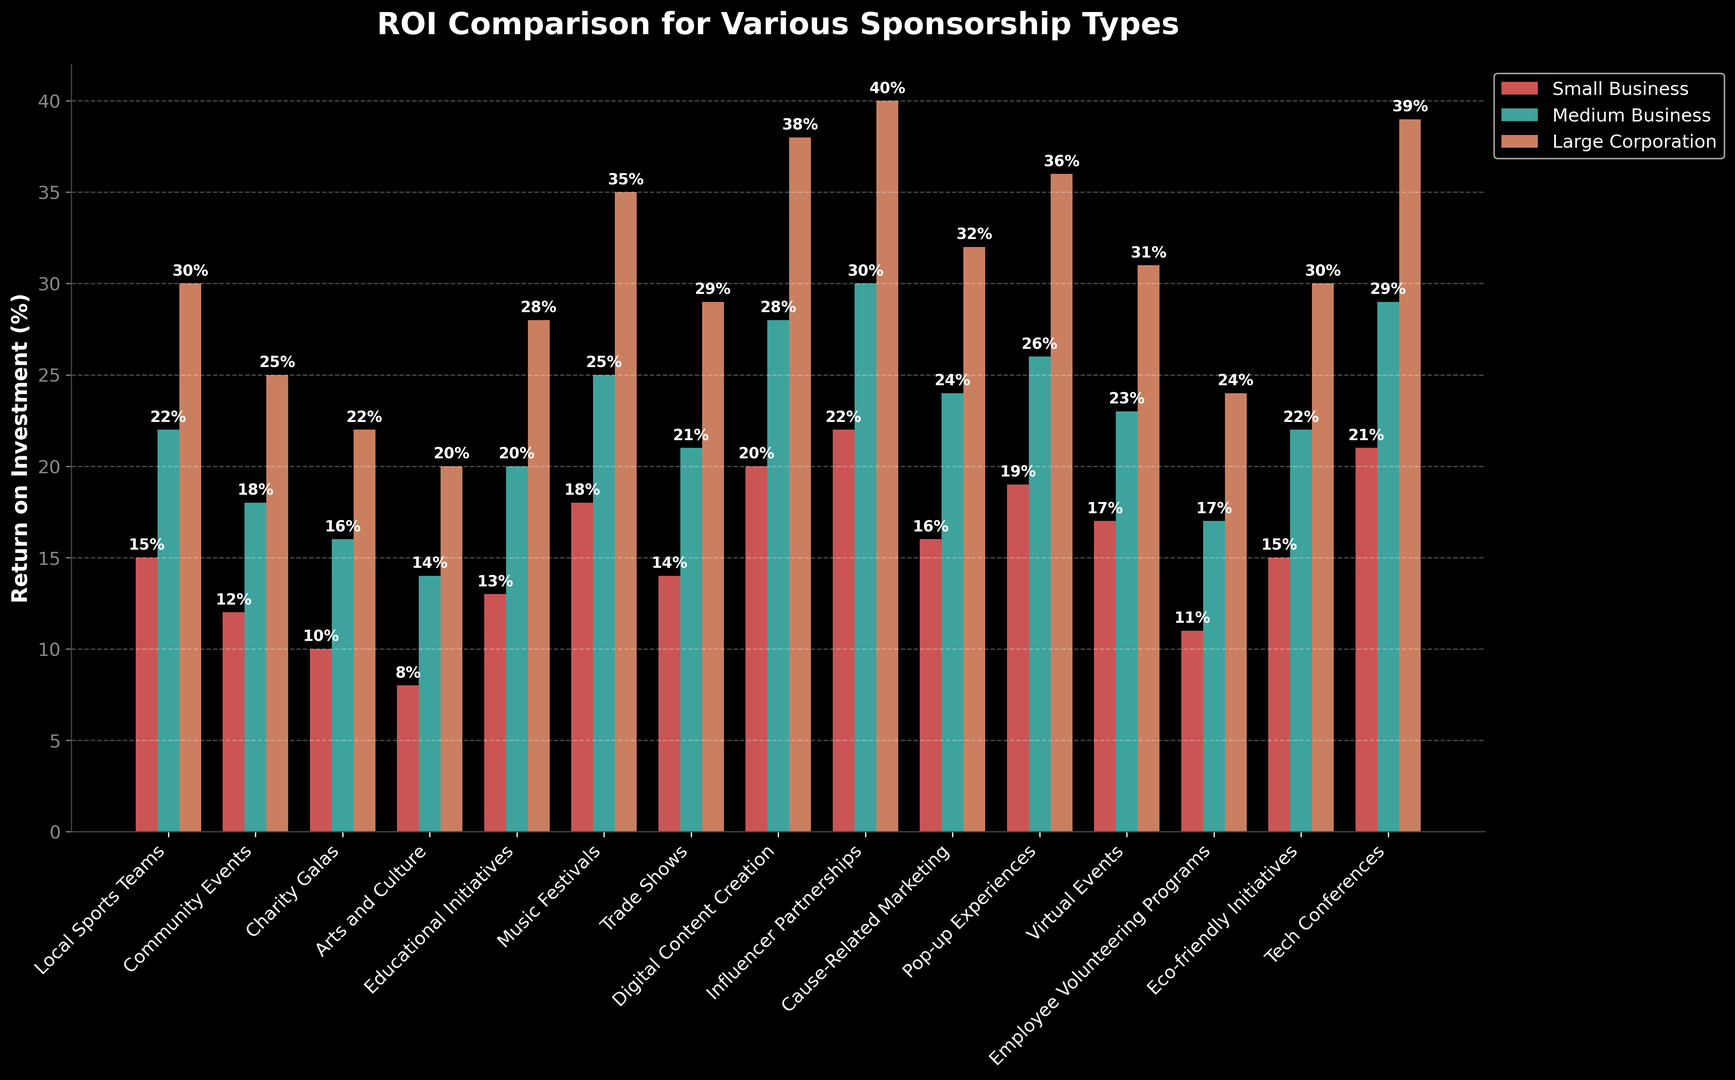What's the highest ROI percentage for small businesses? To find the highest ROI percentage for small businesses, look at the heights of the red bars for different sponsorship types. The highest bar represents the "Influencer Partnerships" with an ROI of 22%.
Answer: 22% Which sponsorship type has the lowest ROI for medium businesses? To determine the lowest ROI for medium businesses, compare the heights of all the green bars. The shortest green bar is for "Arts and Culture" with an ROI of 14%.
Answer: Arts and Culture For large corporations, which two sponsorship types have the same ROI? Observe the heights of the orange bars and find any two bars that are of equal height. Both "Local Sports Teams" and "Eco-friendly Initiatives" have an ROI of 30%.
Answer: Local Sports Teams and Eco-friendly Initiatives How much higher is the ROI for digital content creation compared to trade shows for small businesses? Look at the red bars for both "Digital Content Creation" and "Trade Shows." "Digital Content Creation" has an ROI of 20%, and "Trade Shows" has an ROI of 14%. Calculate the difference: 20% - 14% = 6%.
Answer: 6% Which sponsorship type shows the highest average ROI across all business types? Calculate the average ROI for each sponsorship type by adding the ROI percentages for small, medium, and large businesses and dividing by 3. The "Influencer Partnerships" have averages of (22% + 30% + 40%)/3 = 30%, the highest among all.
Answer: Influencer Partnerships Compare the ROI for educational initiatives between small and medium businesses. Which one is higher? Compare the heights of the red bar (small business) and the green bar (medium business) for "Educational Initiatives". The red bar is 13%, and the green bar is 20%. The medium business has a higher ROI.
Answer: Medium Business What is the combined ROI for large corporations in both music festivals and tech conferences? Sum the ROI percentages for large corporations in "Music Festivals" (35%) and "Tech Conferences" (39%): 35% + 39% = 74%.
Answer: 74% How does the ROI for cause-related marketing compare to virtual events for medium businesses? Compare the heights of the green bars for "Cause-Related Marketing" (24%) and "Virtual Events" (23%). The ROI for "Cause-Related Marketing" is slightly higher.
Answer: Cause-Related Marketing Which sponsorship type has the closest ROI values across all business types? Look for sponsorship types where the red, green, and orange bars are nearly the same height. "Community Events" have ROI of 12% (small), 18% (medium), and 25% (large), which are relatively close compared to the other categories.
Answer: Community Events 